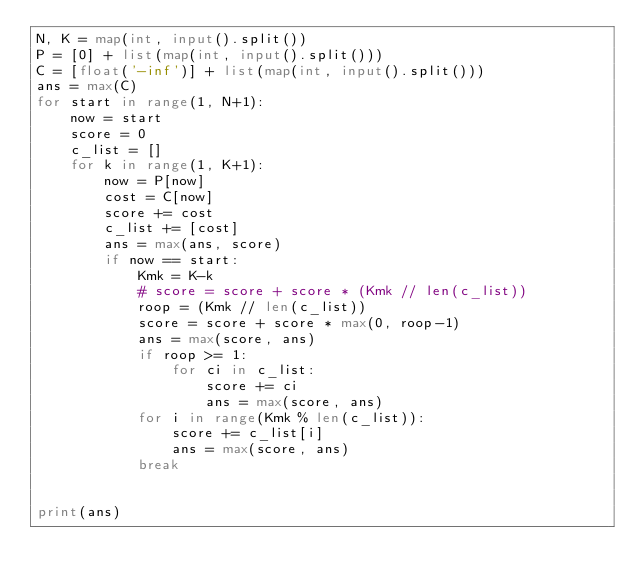<code> <loc_0><loc_0><loc_500><loc_500><_Python_>N, K = map(int, input().split())
P = [0] + list(map(int, input().split()))
C = [float('-inf')] + list(map(int, input().split()))
ans = max(C)
for start in range(1, N+1):
    now = start
    score = 0
    c_list = []
    for k in range(1, K+1):
        now = P[now]
        cost = C[now]
        score += cost
        c_list += [cost]
        ans = max(ans, score)
        if now == start:
            Kmk = K-k
            # score = score + score * (Kmk // len(c_list))
            roop = (Kmk // len(c_list))
            score = score + score * max(0, roop-1)
            ans = max(score, ans)
            if roop >= 1:
                for ci in c_list:
                    score += ci
                    ans = max(score, ans)
            for i in range(Kmk % len(c_list)):
                score += c_list[i]
                ans = max(score, ans)
            break
        

print(ans)</code> 